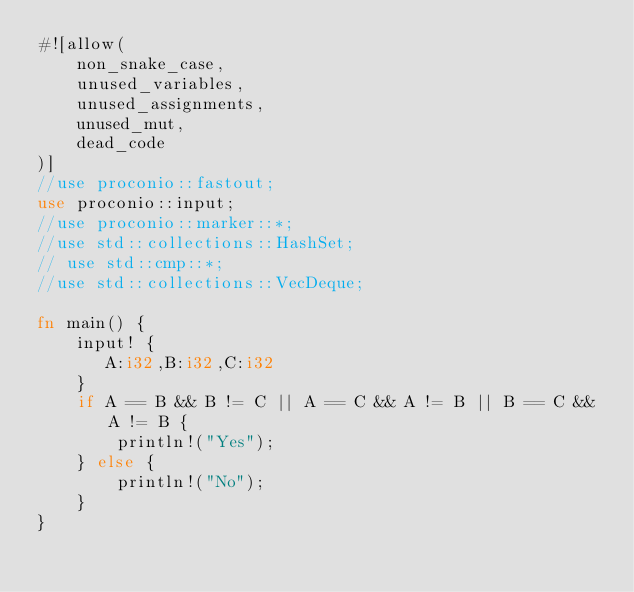<code> <loc_0><loc_0><loc_500><loc_500><_Rust_>#![allow(
    non_snake_case,
    unused_variables,
    unused_assignments,
    unused_mut,
    dead_code
)]
//use proconio::fastout;
use proconio::input;
//use proconio::marker::*;
//use std::collections::HashSet;
// use std::cmp::*;
//use std::collections::VecDeque;

fn main() {
    input! {
       A:i32,B:i32,C:i32
    }
    if A == B && B != C || A == C && A != B || B == C && A != B {
        println!("Yes");
    } else {
        println!("No");
    }
}
</code> 